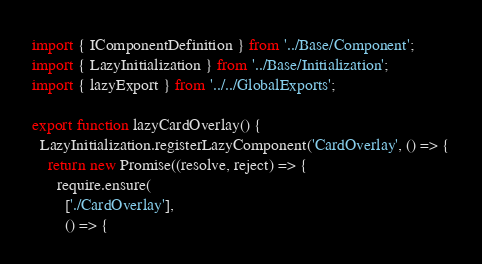<code> <loc_0><loc_0><loc_500><loc_500><_TypeScript_>import { IComponentDefinition } from '../Base/Component';
import { LazyInitialization } from '../Base/Initialization';
import { lazyExport } from '../../GlobalExports';

export function lazyCardOverlay() {
  LazyInitialization.registerLazyComponent('CardOverlay', () => {
    return new Promise((resolve, reject) => {
      require.ensure(
        ['./CardOverlay'],
        () => {</code> 